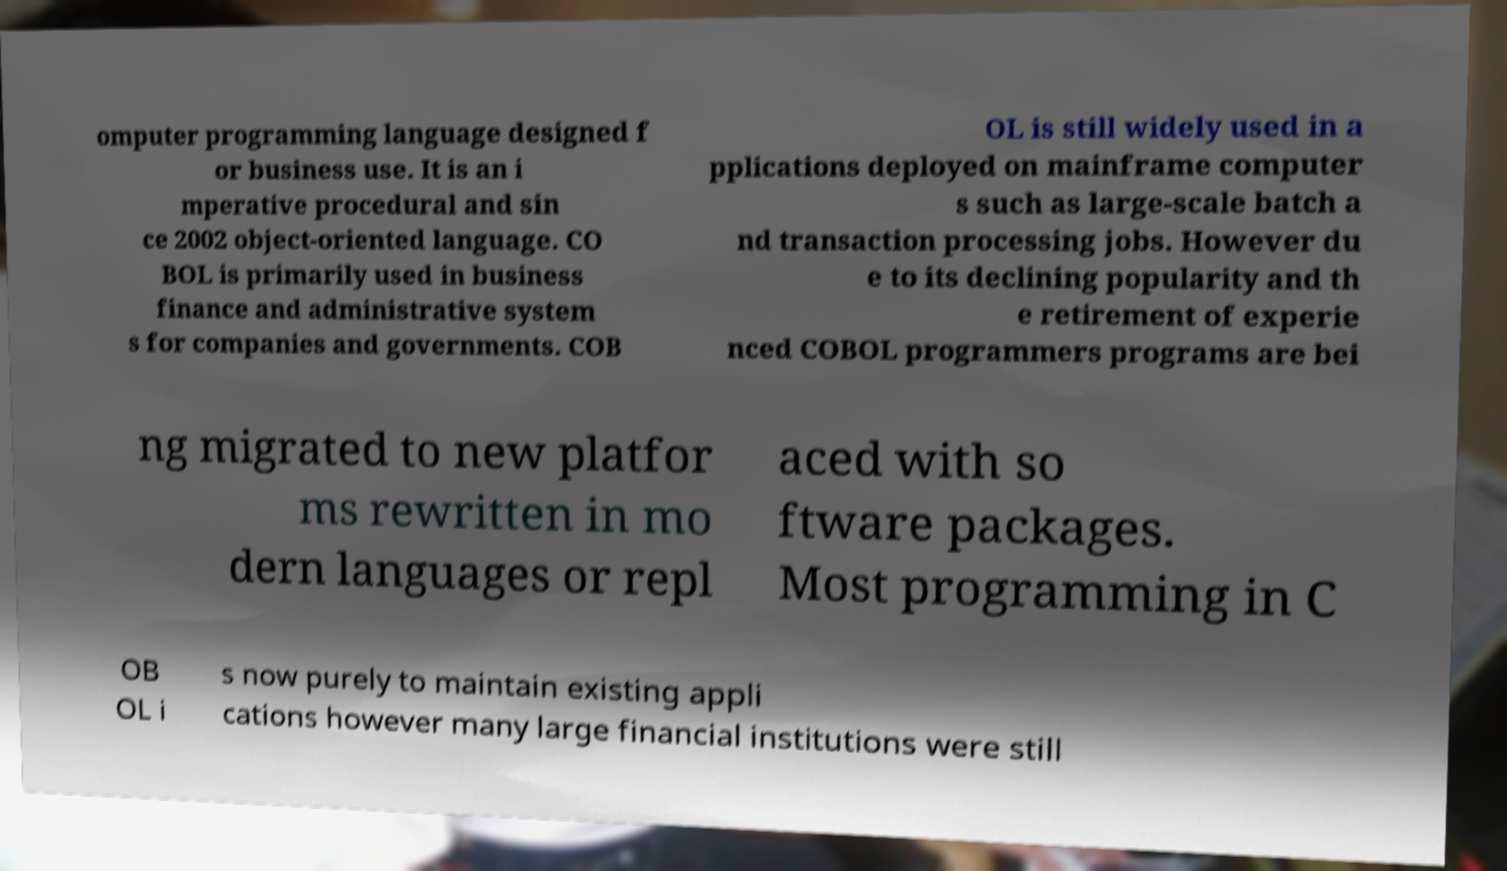Could you extract and type out the text from this image? omputer programming language designed f or business use. It is an i mperative procedural and sin ce 2002 object-oriented language. CO BOL is primarily used in business finance and administrative system s for companies and governments. COB OL is still widely used in a pplications deployed on mainframe computer s such as large-scale batch a nd transaction processing jobs. However du e to its declining popularity and th e retirement of experie nced COBOL programmers programs are bei ng migrated to new platfor ms rewritten in mo dern languages or repl aced with so ftware packages. Most programming in C OB OL i s now purely to maintain existing appli cations however many large financial institutions were still 